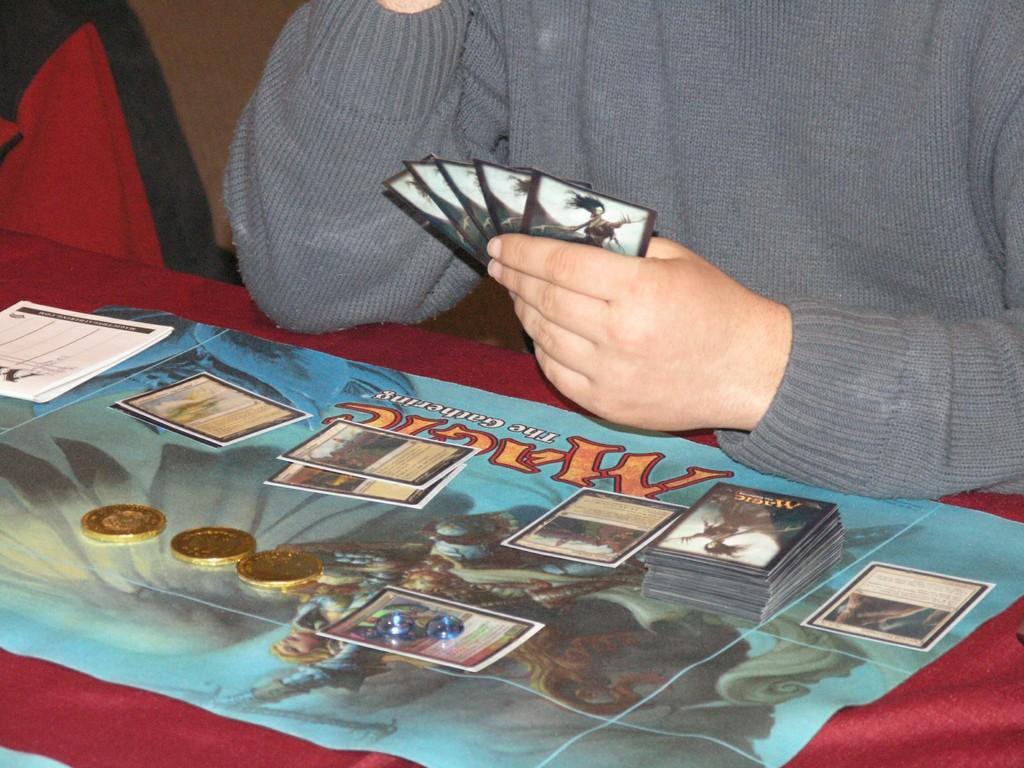Describe this image in one or two sentences. In this image, we can see a person who´is face is not visible wearing clothes and holding cards with his hand. There is a table at the bottom of the image contains cards and coins. 